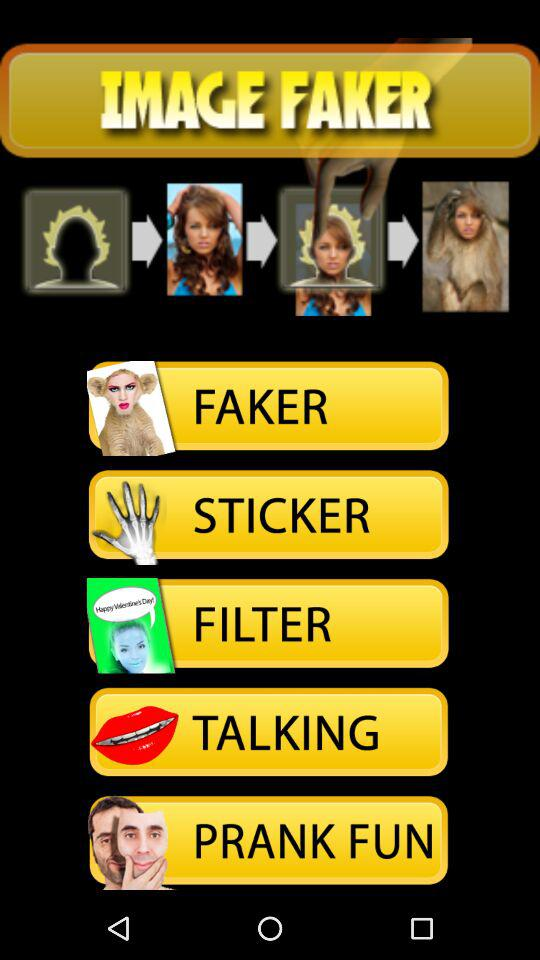Which option is selected?
When the provided information is insufficient, respond with <no answer>. <no answer> 